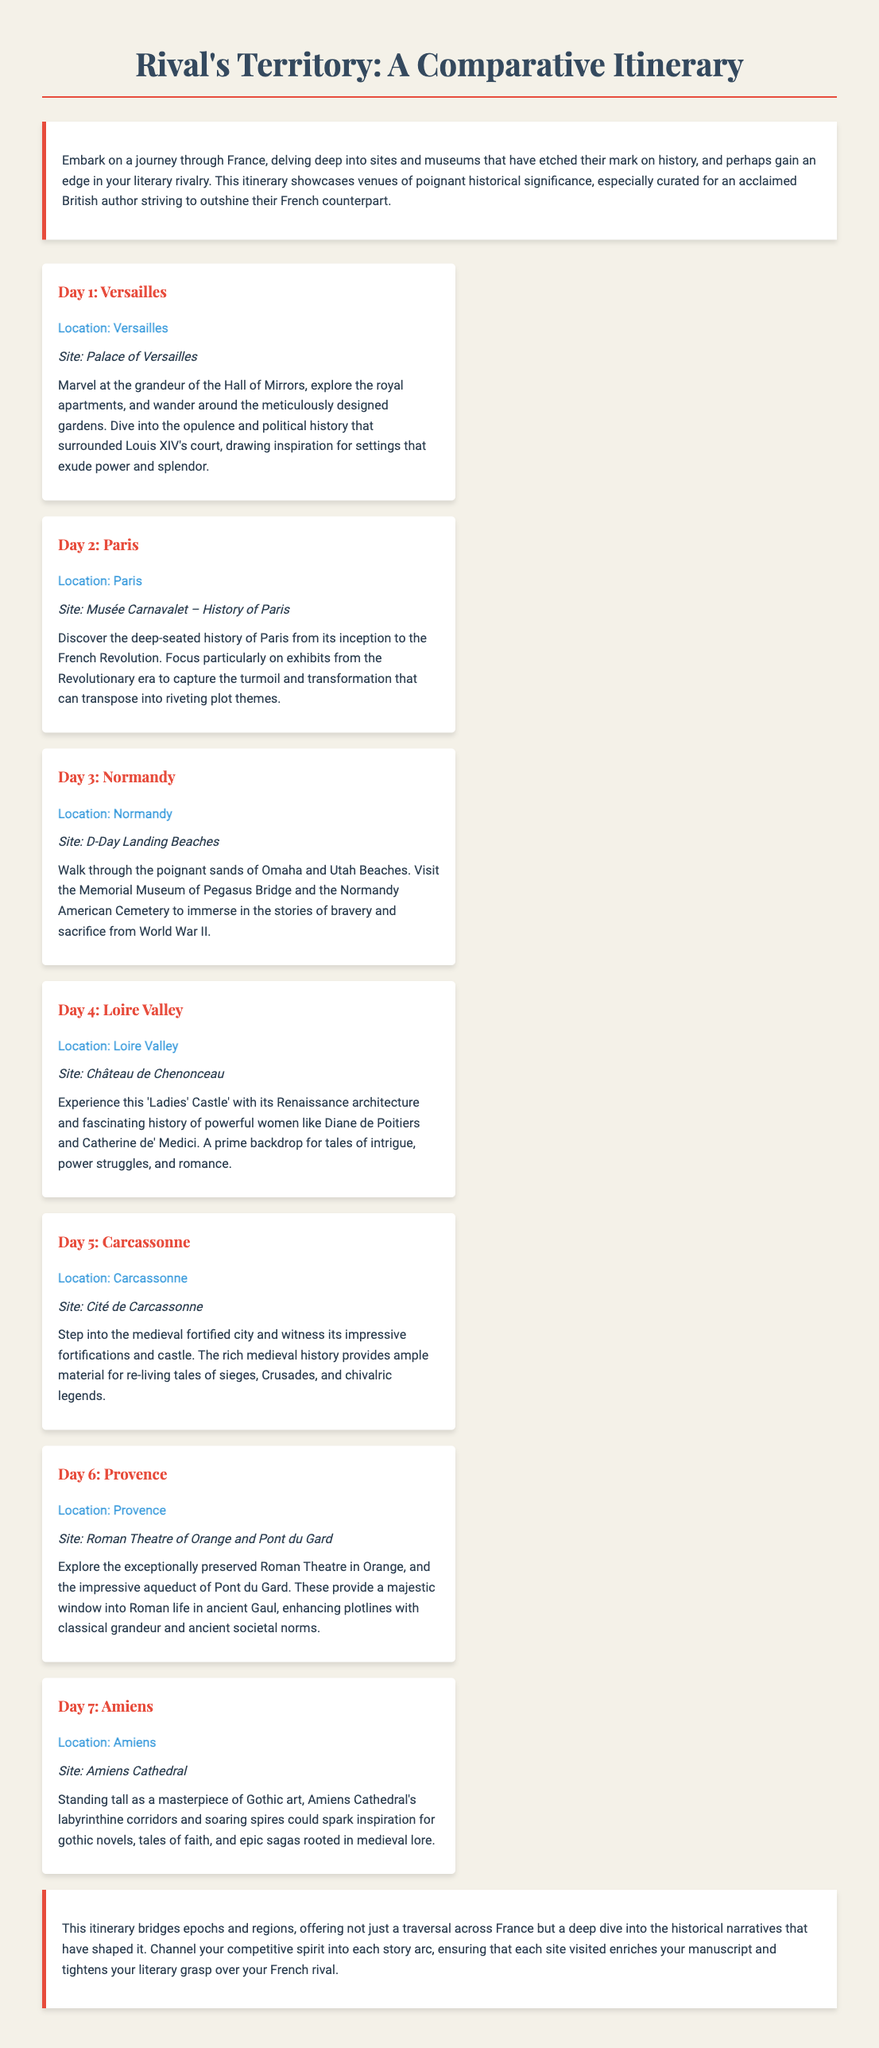What is the title of the itinerary? The title is prominently displayed at the top of the document.
Answer: Rival's Territory: A Comparative Itinerary What location is highlighted on Day 3? Each day specifies a location, with Day 3 being unique to its own site.
Answer: Normandy Which site is visited on Day 5? The site is mentioned explicitly for Day 5 in the itinerary.
Answer: Cité de Carcassonne How many days are included in the itinerary? The itinerary is structured with a clear enumeration of days.
Answer: 7 What historical period can be explored at the Musée Carnavalet? The document specifies the focus of the museum's exhibits for historical context.
Answer: French Revolution What kind of architecture is featured at the Château de Chenonceau? The document describes the architectural style of the château in detail.
Answer: Renaissance architecture Which thematic element is emphasized at Amiens Cathedral? The document references a particular literary theme inspired by the cathedral's features.
Answer: Gothic art How does the itinerary aim to benefit the British author? The introduction of the itinerary provides insight into its purpose and benefits.
Answer: Outshine their French counterpart 